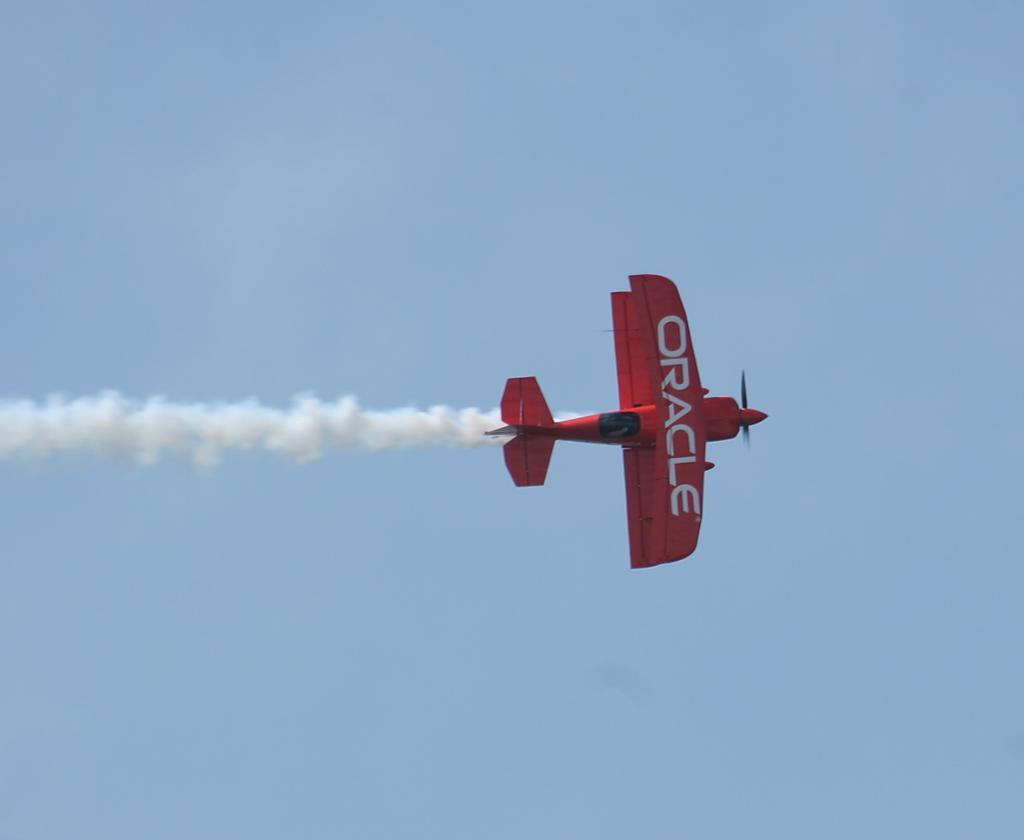What is the main subject of the image? The main subject of the image is an airplane. Where is the airplane located in the image? The airplane is in the center of the image. What can be seen in the background of the image? There is a sky visible in the background of the image. How many servants are attending to the airplane in the image? There are no servants present in the image; it only features an airplane and a sky. What type of chess piece can be seen on the wing of the airplane? There are no chess pieces visible on the airplane in the image. 